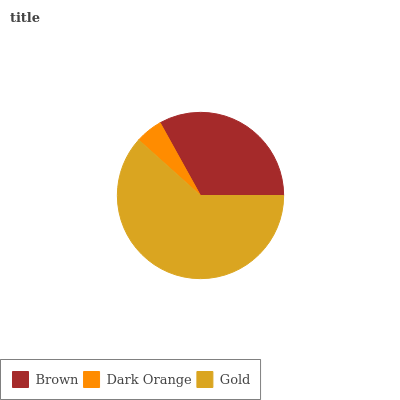Is Dark Orange the minimum?
Answer yes or no. Yes. Is Gold the maximum?
Answer yes or no. Yes. Is Gold the minimum?
Answer yes or no. No. Is Dark Orange the maximum?
Answer yes or no. No. Is Gold greater than Dark Orange?
Answer yes or no. Yes. Is Dark Orange less than Gold?
Answer yes or no. Yes. Is Dark Orange greater than Gold?
Answer yes or no. No. Is Gold less than Dark Orange?
Answer yes or no. No. Is Brown the high median?
Answer yes or no. Yes. Is Brown the low median?
Answer yes or no. Yes. Is Dark Orange the high median?
Answer yes or no. No. Is Dark Orange the low median?
Answer yes or no. No. 